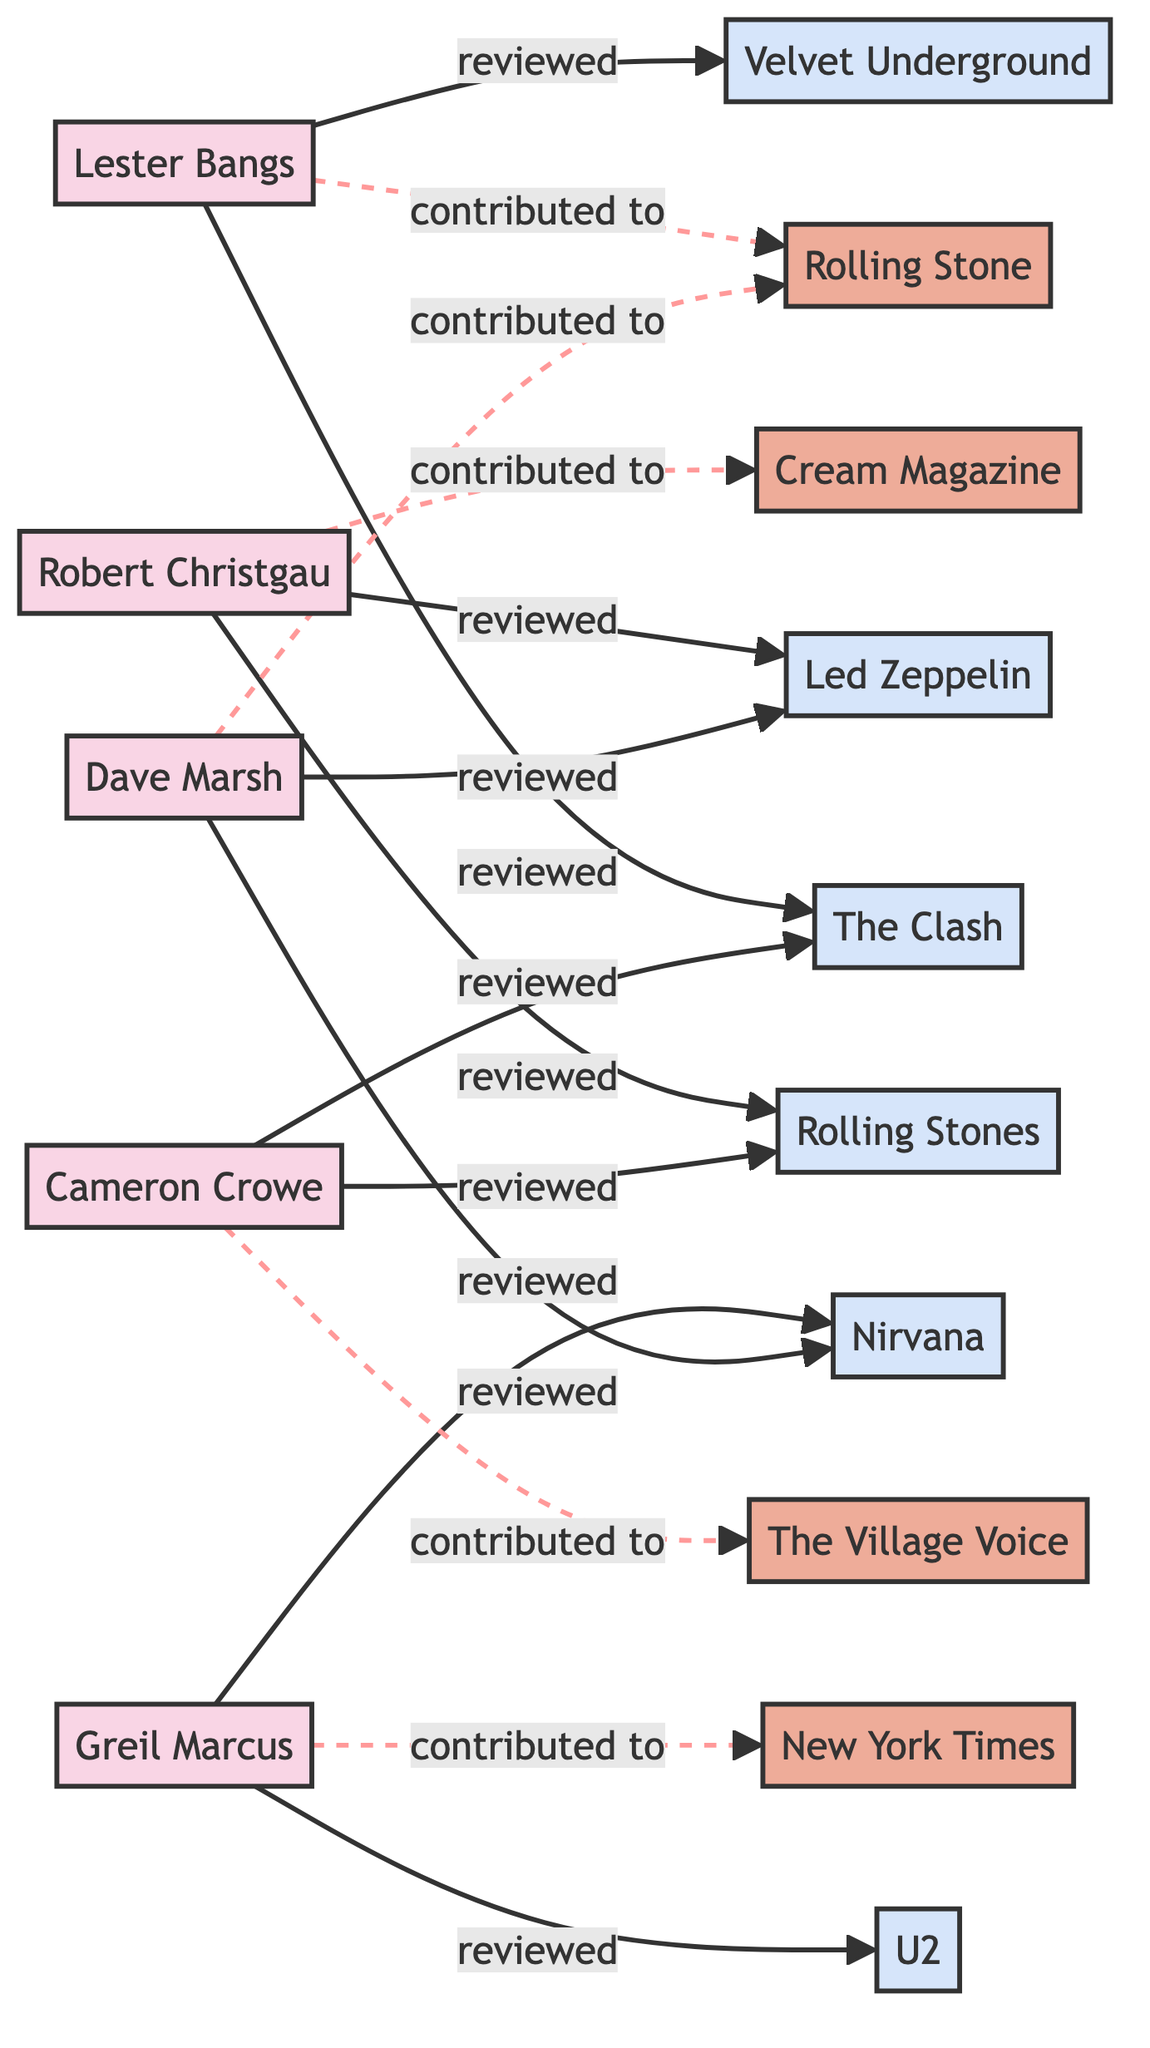What is the total number of critics in the diagram? There are five critics listed as nodes in the diagram: Lester Bangs, Robert Christgau, Greil Marcus, Cameron Crowe, and Dave Marsh.
Answer: 5 Which band was reviewed by both Lester Bangs and Cameron Crowe? The diagram shows that both critics reviewed The Clash, as indicated by the edges connecting them to the band.
Answer: The Clash How many publications are represented in the diagram? The nodes labeled as publications are Rolling Stone Magazine, Cream Magazine, New York Times, and The Village Voice, totaling four publications.
Answer: 4 Which critic contributed to Rolling Stone Magazine? The edge labeled "contributed to" from Lester Bangs to Rolling Stone Magazine indicates that he contributed to this publication.
Answer: Lester Bangs How many bands were reviewed by Robert Christgau? Robert Christgau has edges connecting him to two bands, Led Zeppelin and The Rolling Stones, indicating that he reviewed two bands in total.
Answer: 2 Which band was reviewed by the most critics? By examining the edges, both The Clash and The Rolling Stones were reviewed by two critics, which is the highest count.
Answer: The Clash and The Rolling Stones What type of nodes are connected to the publication labeled "Cream Magazine"? Cream Magazine only has one edge leading to Robert Christgau, indicating that he is the only critic connected to it.
Answer: Critic Which two critics reviewed Nirvana? The diagram shows that Greil Marcus and Dave Marsh both reviewed Nirvana, as indicated by the edges connecting them to the band.
Answer: Greil Marcus and Dave Marsh How many edges are there total in the diagram? By counting all the connections represented in the edges, we find a total of ten edges connecting critics and bands, along with the five edges contributing to publications. The total is thus fifteen edges overall.
Answer: 15 